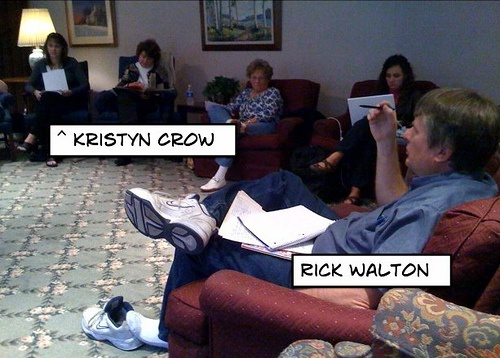Describe the objects in this image and their specific colors. I can see people in black, white, navy, and gray tones, chair in black, maroon, brown, and white tones, couch in black, maroon, and brown tones, chair in black, gray, and darkgray tones, and couch in black, maroon, and purple tones in this image. 